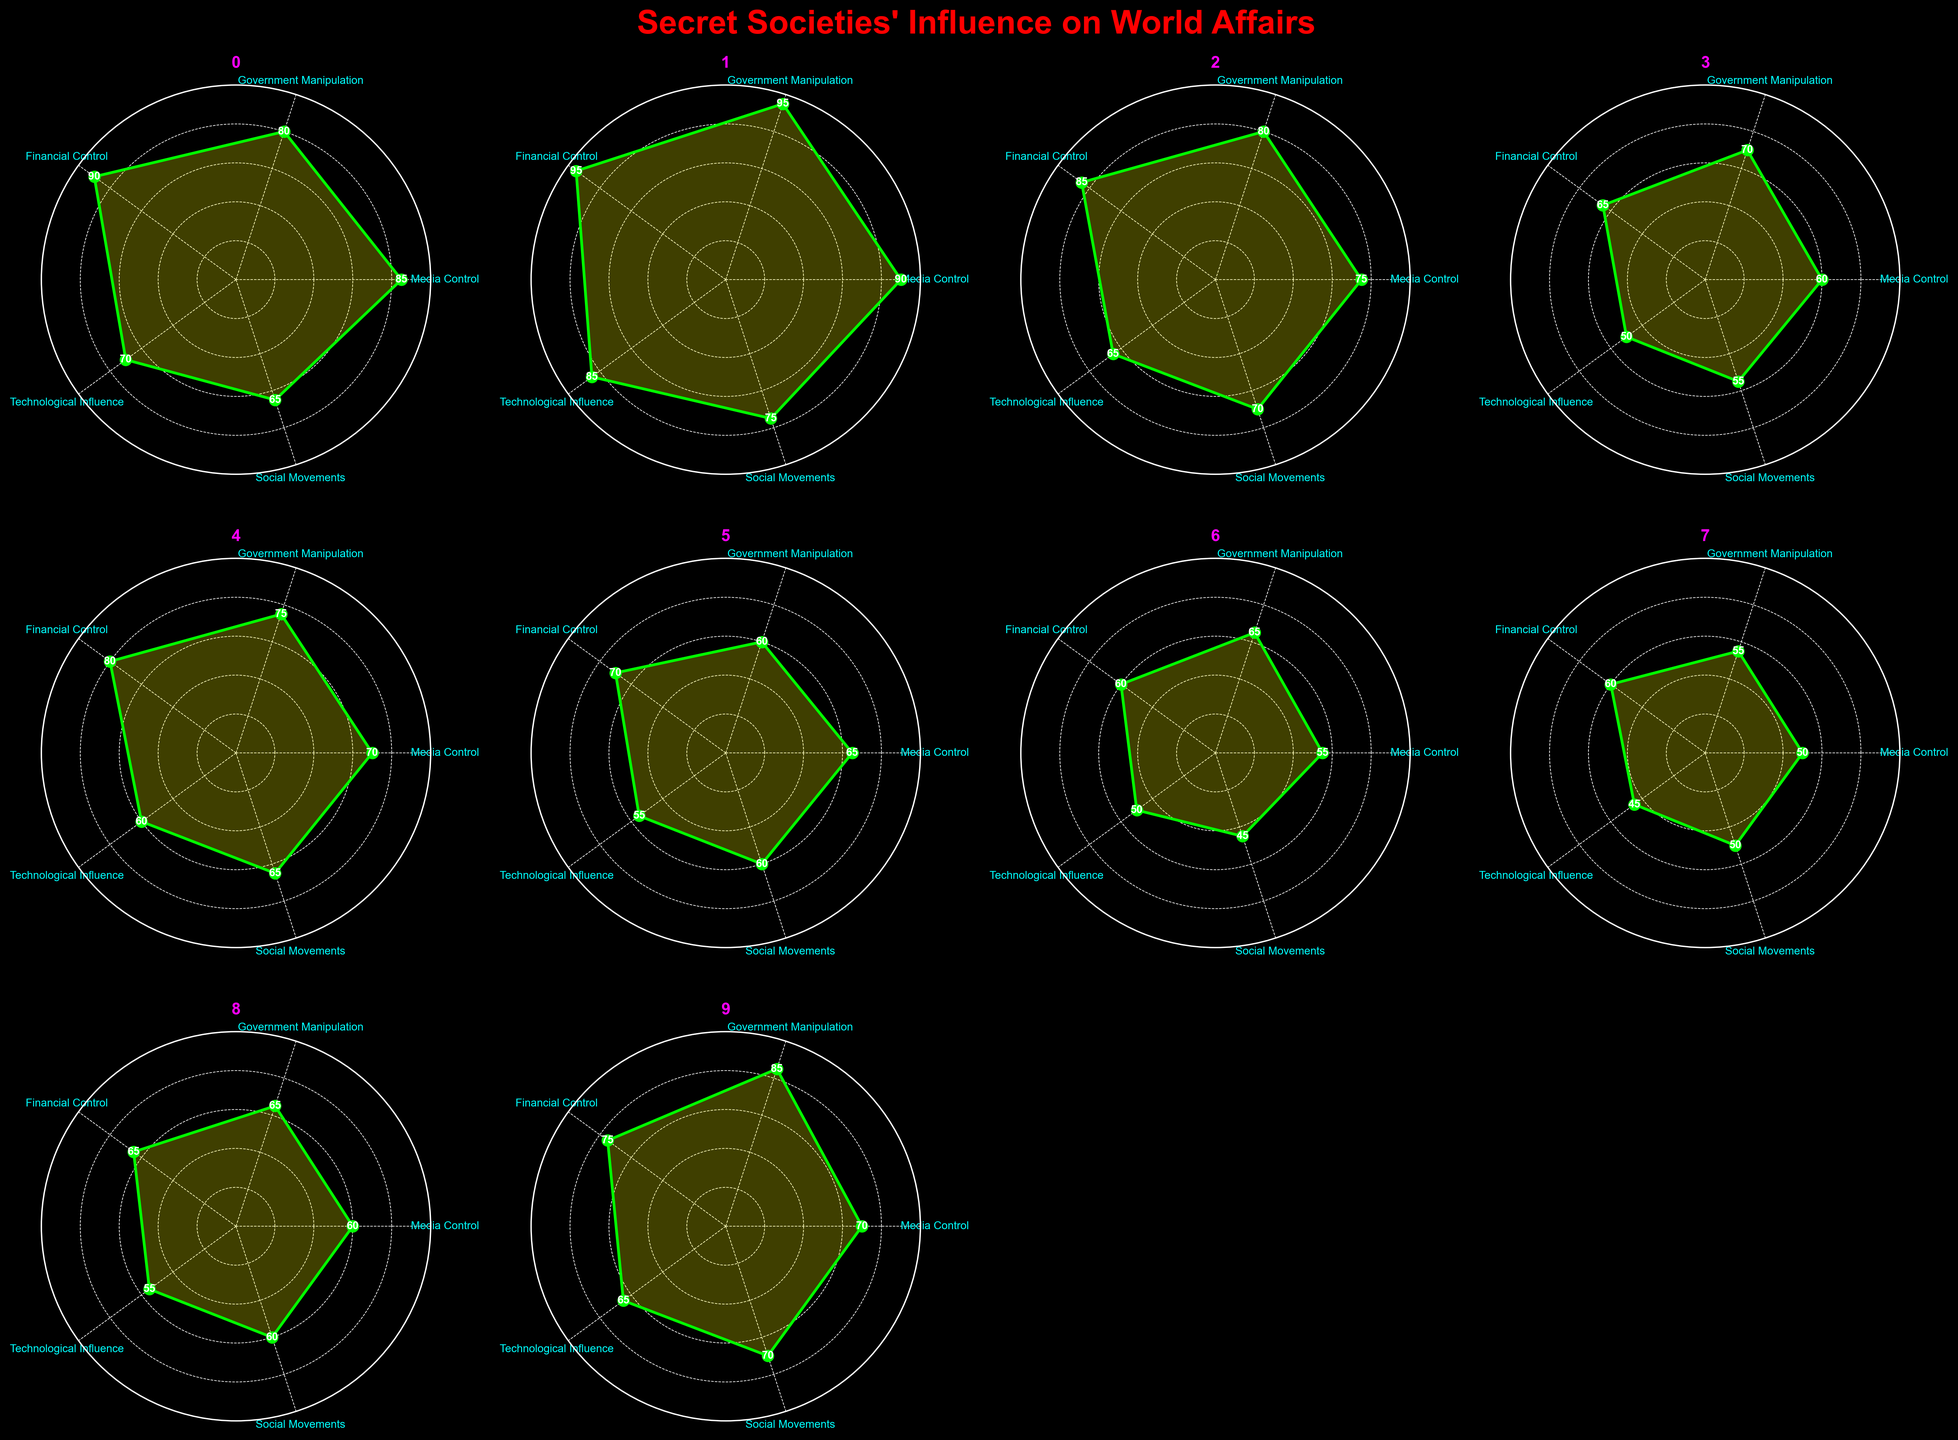what is the highest Media Control value and which secret society does it belong to? The highest Media Control value is found by comparing the Media Control values of all secret societies. The highest value is 90, which belongs to the Illuminati.
Answer: 90, Illuminati which secret society has the lowest Social Movements score? To find this, compare the Social Movements scores of all secret societies. The lowest score is 45, which belongs to the Bohemian Grove.
Answer: Bohemian Grove among Freemasons, Illuminati, and Bilderberg Group, which has the highest Technological Influence? Compare the Technological Influence scores of these three groups: Freemasons (70), Illuminati (85), and Bilderberg Group (65). The highest Technological Influence is 85, belonging to the Illuminati.
Answer: Illuminati what is the median Financial Control value? The Financial Control values are sorted as follows: 60, 60, 65, 65, 70, 75, 80, 85, 90, 95. The median of these values is the average of the 5th and 6th values, which are 70 and 75, giving (70+75)/2 = 72.5.
Answer: 72.5 does the Trilateral Commission have greater Government Manipulation or Financial Control? Checking the values for the Trilateral Commission: Government Manipulation is 75, and Financial Control is 80. Financial Control is greater.
Answer: Financial Control which category shows the least variation in scores among all secret societies? To determine this, find the range for each category:
- Media Control: 90 - 50 = 40
- Government Manipulation: 95 - 55 = 40
- Financial Control: 95 - 60 = 35
- Technological Influence: 85 - 45 = 40
- Social Movements: 75 - 45 = 30
Social Movements shows the least variation.
Answer: Social Movements which secret society has the highest sum of all categories combined? Calculate the sum for each society:
- Freemasons: 85+80+90+70+65 = 390
- Illuminati: 90+95+95+85+75 = 440
- Bilderberg Group: 75+80+85+65+70 = 375
- Skull and Bones: 60+70+65+50+55 = 300
- Trilateral Commission: 70+75+80+60+65 = 350
- Club of Rome: 65+60+70+55+60 = 310
- Bohemian Grove: 55+65+60+50+45 = 275
- Rosicrucians: 50+55+60+45+50 = 260
- Knights Templar: 60+65+65+55+60 = 305
- Committee of 300: 70+85+75+65+70 = 365
The highest sum is 440, belonging to Illuminati.
Answer: Illuminati 